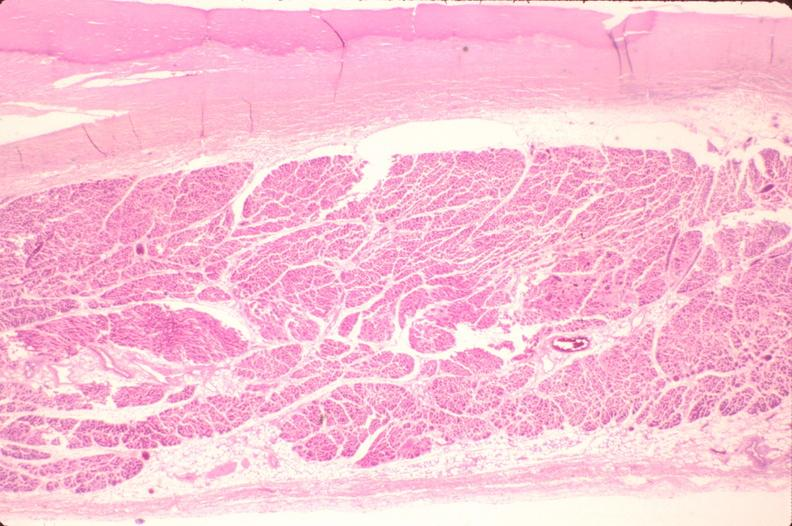where is this in?
Answer the question using a single word or phrase. In heart 